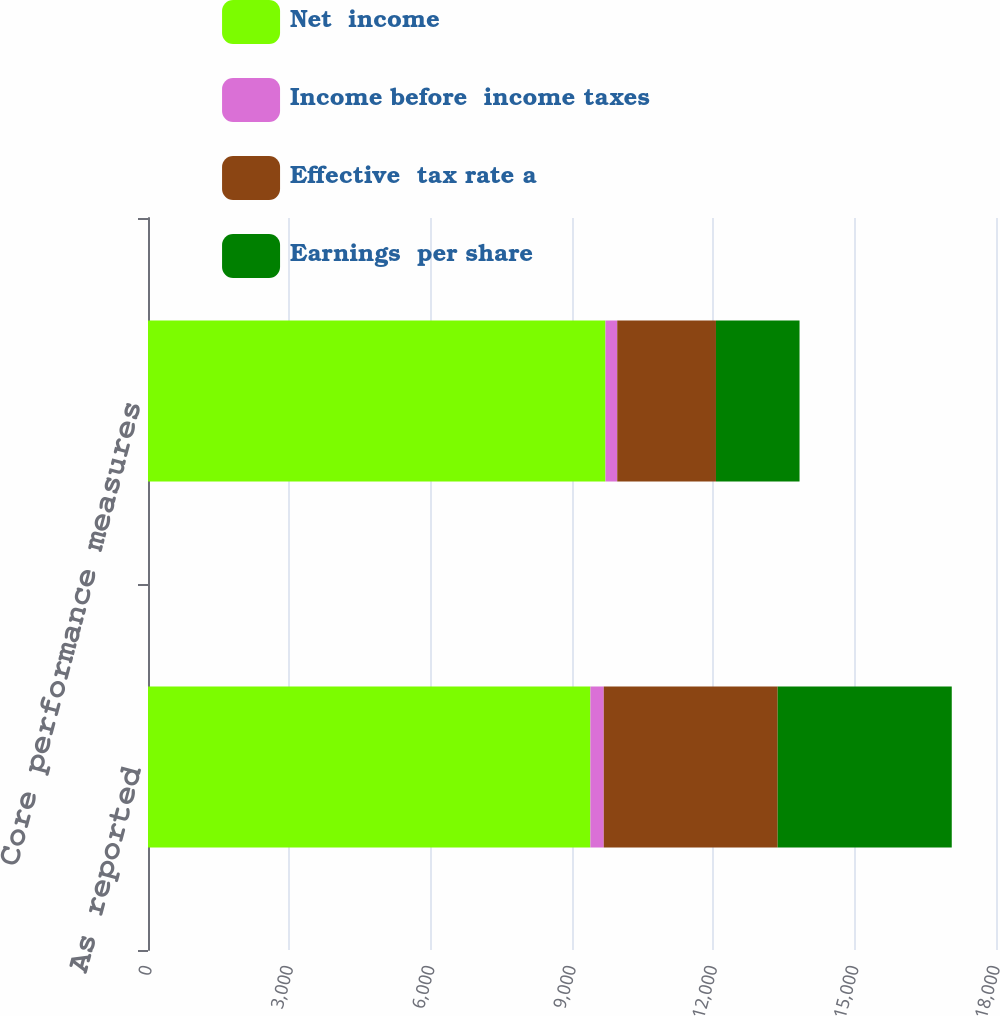<chart> <loc_0><loc_0><loc_500><loc_500><stacked_bar_chart><ecel><fcel>As reported<fcel>Core performance measures<nl><fcel>Net  income<fcel>9390<fcel>9710<nl><fcel>Income before  income taxes<fcel>284<fcel>250<nl><fcel>Effective  tax rate a<fcel>3692<fcel>2096<nl><fcel>Earnings  per share<fcel>3695<fcel>1774<nl></chart> 